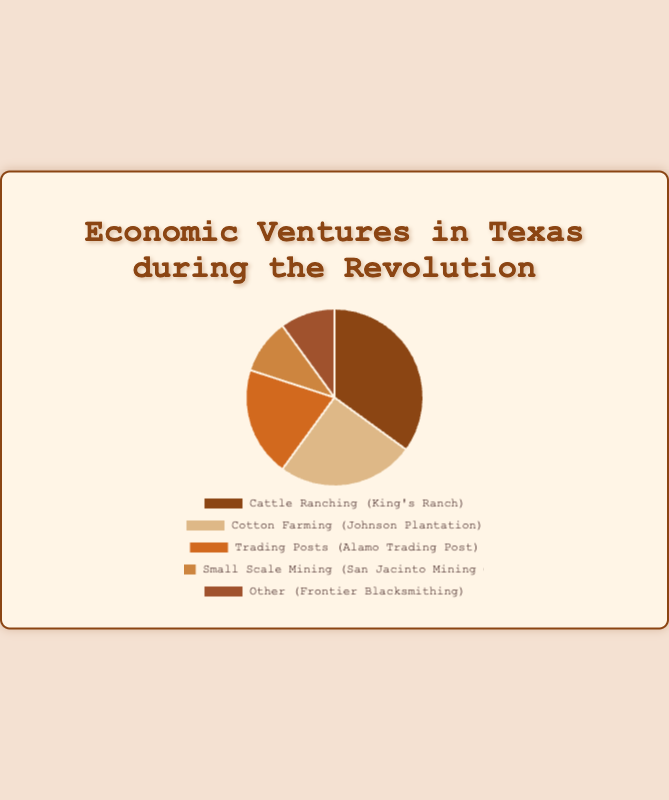Which economic venture contributes the most to the Texas economy during the Revolution? The chart shows that Cattle Ranching, represented by King's Ranch, has the largest slice of the pie at 35%. This is the highest percentage compared to the other ventures.
Answer: Cattle Ranching What is the total economic contribution percentage of the top two economic ventures? Cattle Ranching and Cotton Farming are the top two economic ventures. Their percentages are 35% and 25% respectively. Adding these together gives 35 + 25 = 60%.
Answer: 60% Which economic venture contributes the least to the Texas economy during the Revolution, and what is its percentage? Both Small Scale Mining (San Jacinto Mining Co.) and Other (Frontier Blacksmithing) are tied for the least contribution, each at 10%.
Answer: Small Scale Mining and Other, 10% What is the difference in economic contribution between Cotton Farming and Trading Posts? Cotton Farming (Johnson Plantation) contributes 25%, while Trading Posts (Alamo Trading Post) contribute 20%. The difference is 25 - 20 = 5%.
Answer: 5% How does the economic contribution of Trading Posts compare to the combined contribution of Small Scale Mining and Other ventures? Trading Posts contribute 20%, while Small Scale Mining and Other each contribute 10%. Combined, Small Scale Mining and Other contribute 10 + 10 = 20%. Therefore, Trading Posts' contribution is equal to the combined contribution of Small Scale Mining and Other.
Answer: Equal If Small Scale Mining had contributed 5% more, what would its new economic contribution percentage be? Small Scale Mining is currently at 10%. Adding 5% to this would yield 10 + 5 = 15%.
Answer: 15% What is the average economic contribution percentage of all the ventures listed? The percentages are 35, 25, 20, 10, and 10. Adding these gives 35 + 25 + 20 + 10 + 10 = 100. Dividing by the number of categories (5) gives 100 / 5 = 20%.
Answer: 20% If the economic contributions of Cattle Ranching and Cotton Farming were combined, what percentage of the total would that represent? Cattle Ranching contributes 35%, and Cotton Farming contributes 25%. Combined, they contribute 35 + 25 = 60%.
Answer: 60% Which segment in the pie chart is represented by a brownish shade and what is its economic contribution? The segment that represents Cattle Ranching (King's Ranch) is portrayed in a brownish color and has an economic contribution of 35%.
Answer: Cattle Ranching, 35% 